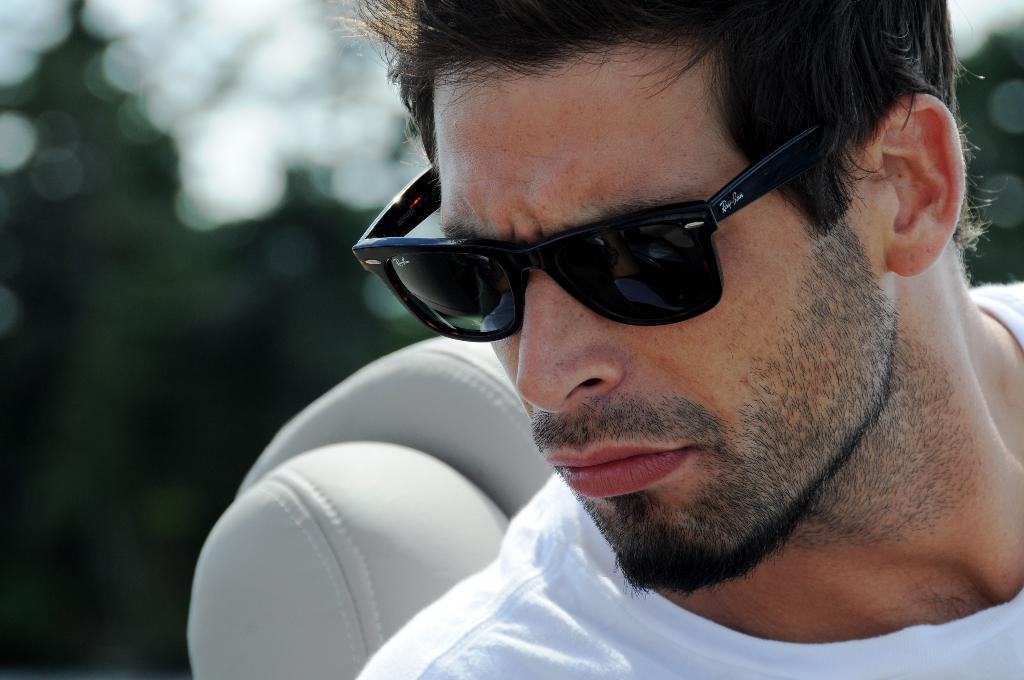Who or what is the main subject in the image? There is a person in the image. Can you describe the setting or surroundings of the person? There is a headrest of a seat behind the person. What type of frog can be seen sitting on the chair in the image? There is no frog or chair present in the image; it only features a person and a headrest of a seat. 